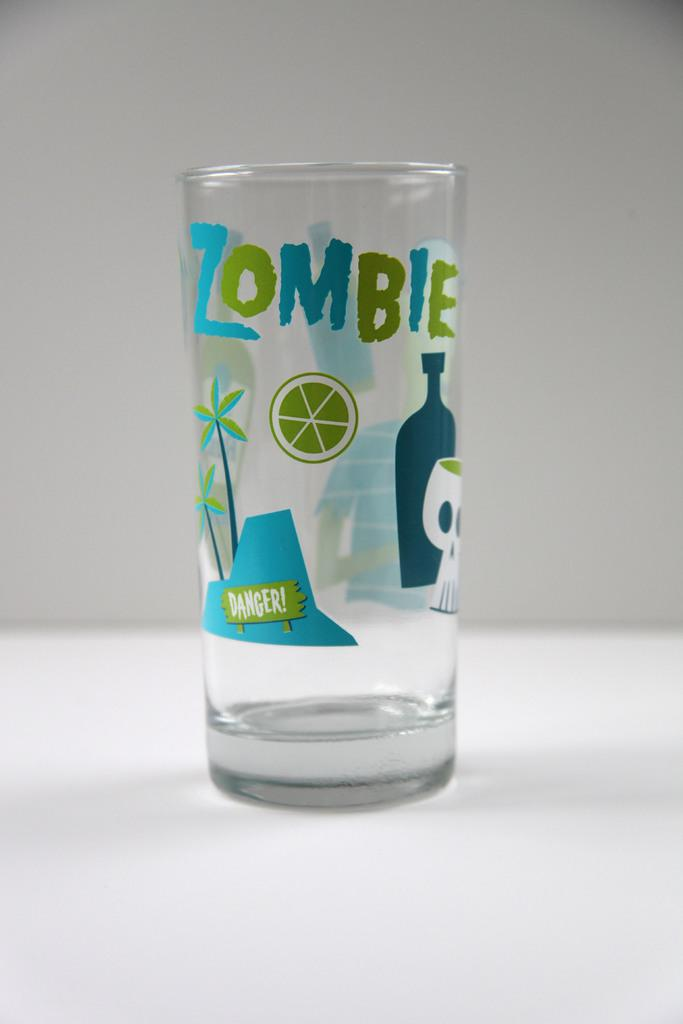<image>
Describe the image concisely. A glass that says Lombie placed on a white surface. 